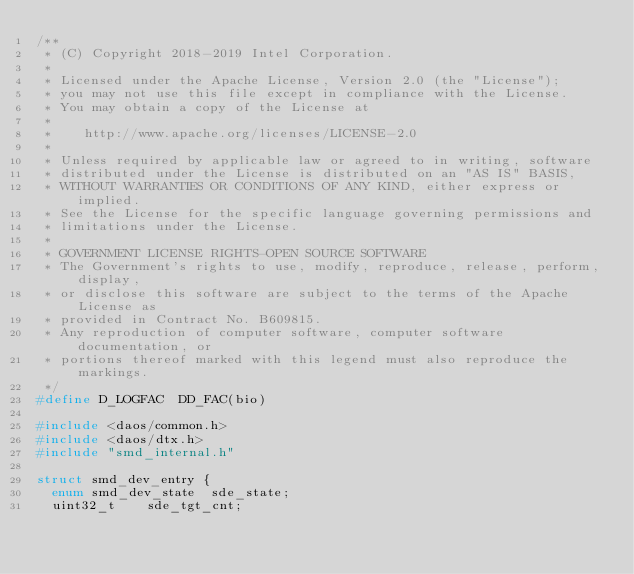<code> <loc_0><loc_0><loc_500><loc_500><_C_>/**
 * (C) Copyright 2018-2019 Intel Corporation.
 *
 * Licensed under the Apache License, Version 2.0 (the "License");
 * you may not use this file except in compliance with the License.
 * You may obtain a copy of the License at
 *
 *    http://www.apache.org/licenses/LICENSE-2.0
 *
 * Unless required by applicable law or agreed to in writing, software
 * distributed under the License is distributed on an "AS IS" BASIS,
 * WITHOUT WARRANTIES OR CONDITIONS OF ANY KIND, either express or implied.
 * See the License for the specific language governing permissions and
 * limitations under the License.
 *
 * GOVERNMENT LICENSE RIGHTS-OPEN SOURCE SOFTWARE
 * The Government's rights to use, modify, reproduce, release, perform, display,
 * or disclose this software are subject to the terms of the Apache License as
 * provided in Contract No. B609815.
 * Any reproduction of computer software, computer software documentation, or
 * portions thereof marked with this legend must also reproduce the markings.
 */
#define D_LOGFAC	DD_FAC(bio)

#include <daos/common.h>
#include <daos/dtx.h>
#include "smd_internal.h"

struct smd_dev_entry {
	enum smd_dev_state	sde_state;
	uint32_t		sde_tgt_cnt;</code> 